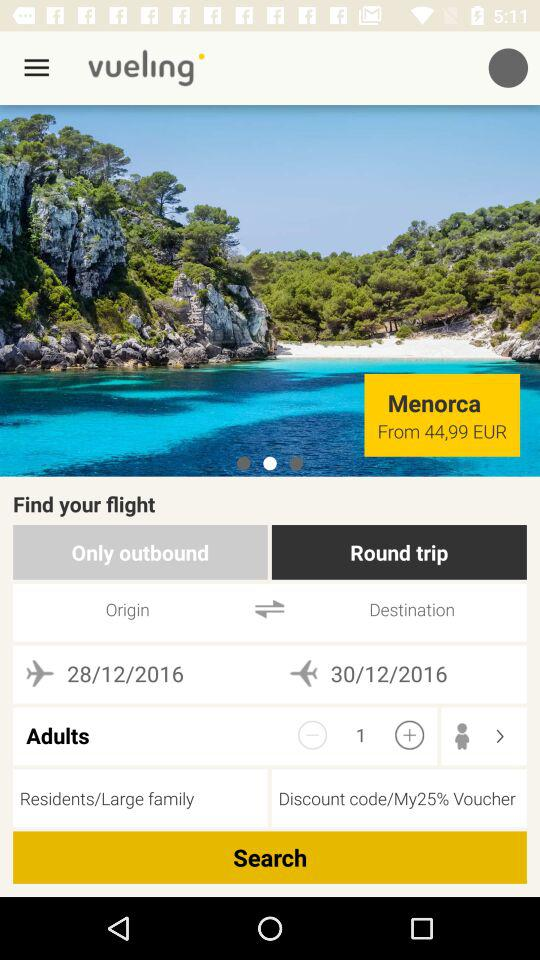How many days are there between the departure and return dates?
Answer the question using a single word or phrase. 2 